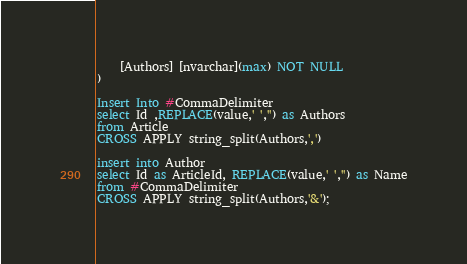<code> <loc_0><loc_0><loc_500><loc_500><_SQL_>	[Authors] [nvarchar](max) NOT NULL
)

Insert Into #CommaDelimiter
select Id ,REPLACE(value,' ','') as Authors
from Article
CROSS APPLY string_split(Authors,',')

insert into Author
select Id as ArticleId, REPLACE(value,' ','') as Name
from #CommaDelimiter
CROSS APPLY string_split(Authors,'&');
</code> 